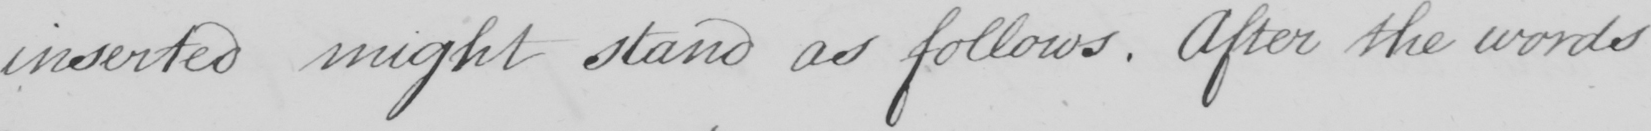What is written in this line of handwriting? inserted might stand as follows . After the words 